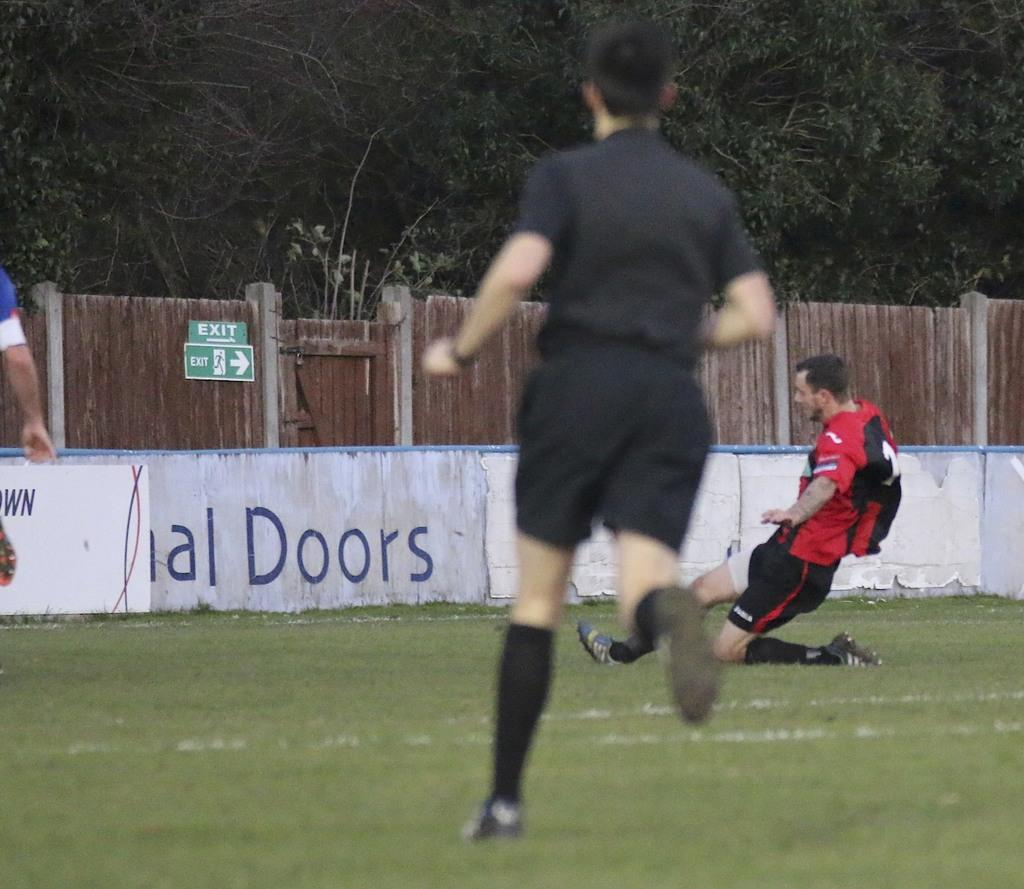What activity are the people in the image engaged in? The people in the image are playing a game. What can be seen in the background of the image? There is a fence and trees in the background of the image. What type of crow is perched on the apparatus in the image? There is no crow or apparatus present in the image. How many soldiers are visible in the army formation in the image? There is no army or soldiers present in the image. 